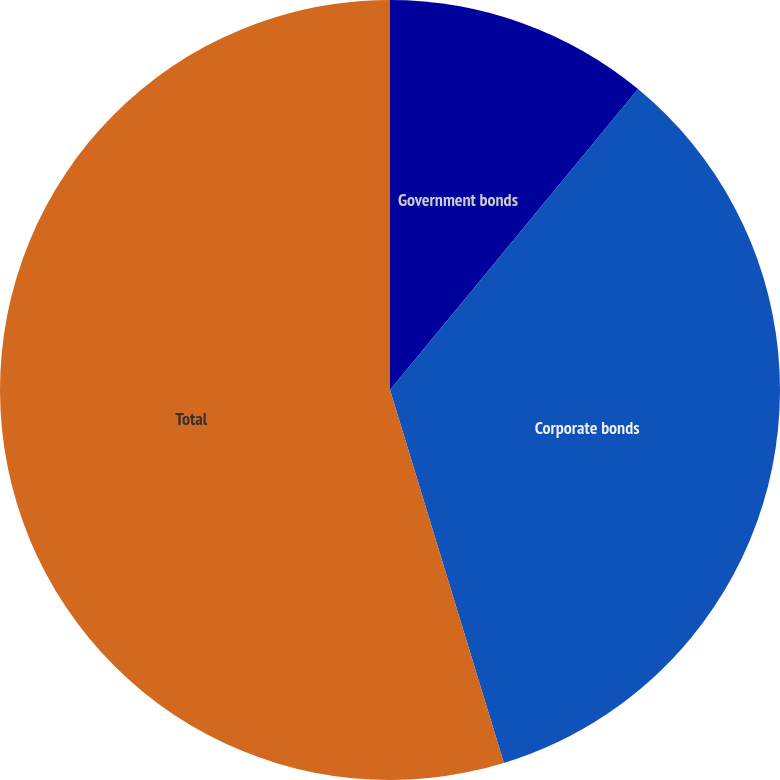Convert chart to OTSL. <chart><loc_0><loc_0><loc_500><loc_500><pie_chart><fcel>Government bonds<fcel>Corporate bonds<fcel>Total<nl><fcel>10.97%<fcel>34.31%<fcel>54.71%<nl></chart> 